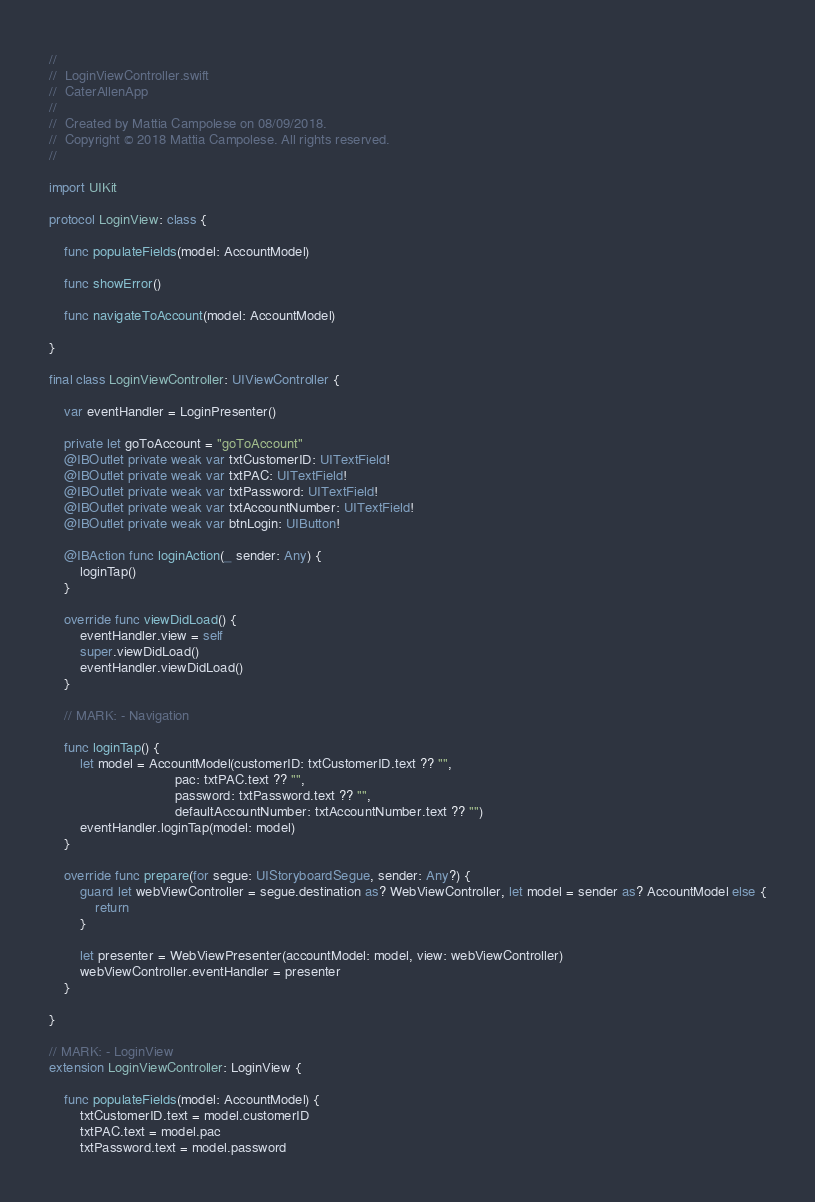Convert code to text. <code><loc_0><loc_0><loc_500><loc_500><_Swift_>//
//  LoginViewController.swift
//  CaterAllenApp
//
//  Created by Mattia Campolese on 08/09/2018.
//  Copyright © 2018 Mattia Campolese. All rights reserved.
//

import UIKit

protocol LoginView: class {
    
    func populateFields(model: AccountModel)
    
    func showError()
        
    func navigateToAccount(model: AccountModel)
    
}

final class LoginViewController: UIViewController {

    var eventHandler = LoginPresenter()
    
    private let goToAccount = "goToAccount"
    @IBOutlet private weak var txtCustomerID: UITextField!
    @IBOutlet private weak var txtPAC: UITextField!
    @IBOutlet private weak var txtPassword: UITextField!
    @IBOutlet private weak var txtAccountNumber: UITextField!
    @IBOutlet private weak var btnLogin: UIButton!
    
    @IBAction func loginAction(_ sender: Any) {
        loginTap()
    }
    
    override func viewDidLoad() {
        eventHandler.view = self
        super.viewDidLoad()
        eventHandler.viewDidLoad()
    }
    
    // MARK: - Navigation

    func loginTap() {
        let model = AccountModel(customerID: txtCustomerID.text ?? "",
                                 pac: txtPAC.text ?? "",
                                 password: txtPassword.text ?? "",
                                 defaultAccountNumber: txtAccountNumber.text ?? "")
        eventHandler.loginTap(model: model)
    }
    
    override func prepare(for segue: UIStoryboardSegue, sender: Any?) {
        guard let webViewController = segue.destination as? WebViewController, let model = sender as? AccountModel else {
            return
        }
        
        let presenter = WebViewPresenter(accountModel: model, view: webViewController)
        webViewController.eventHandler = presenter
    }
    
}

// MARK: - LoginView
extension LoginViewController: LoginView {
    
    func populateFields(model: AccountModel) {
        txtCustomerID.text = model.customerID
        txtPAC.text = model.pac
        txtPassword.text = model.password</code> 